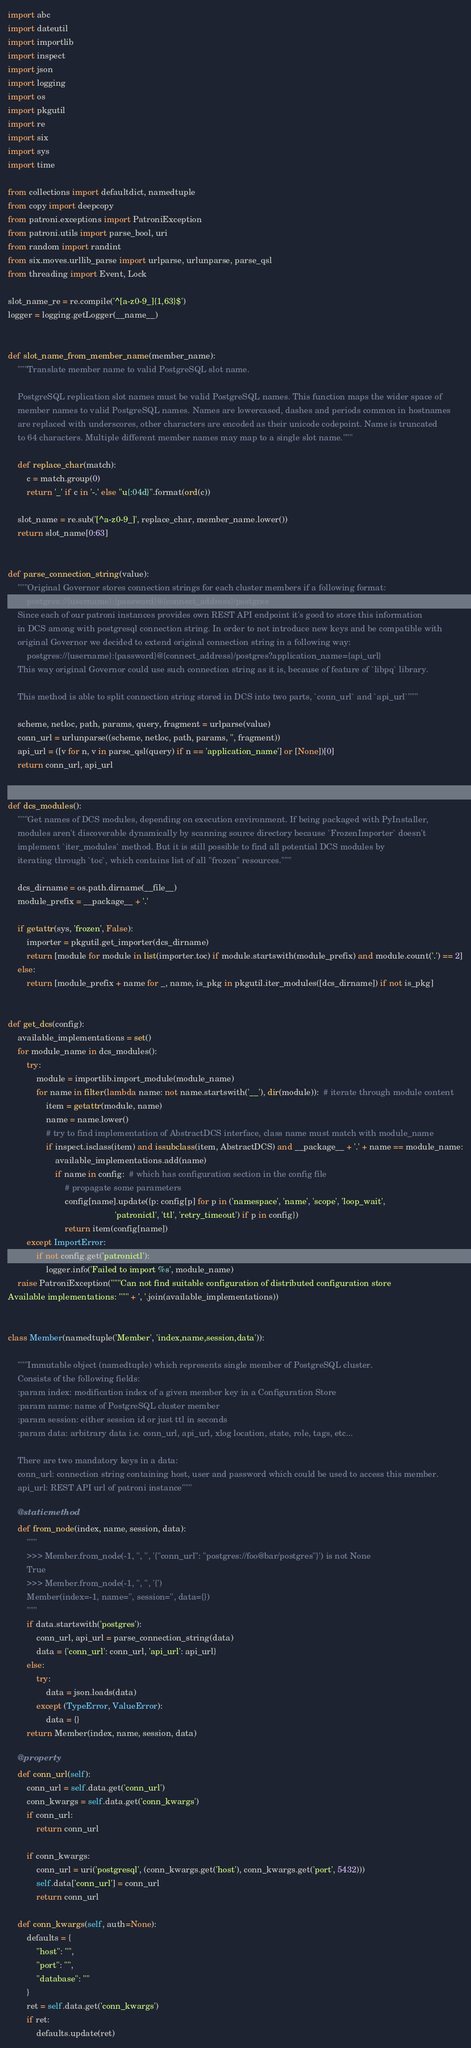<code> <loc_0><loc_0><loc_500><loc_500><_Python_>import abc
import dateutil
import importlib
import inspect
import json
import logging
import os
import pkgutil
import re
import six
import sys
import time

from collections import defaultdict, namedtuple
from copy import deepcopy
from patroni.exceptions import PatroniException
from patroni.utils import parse_bool, uri
from random import randint
from six.moves.urllib_parse import urlparse, urlunparse, parse_qsl
from threading import Event, Lock

slot_name_re = re.compile('^[a-z0-9_]{1,63}$')
logger = logging.getLogger(__name__)


def slot_name_from_member_name(member_name):
    """Translate member name to valid PostgreSQL slot name.

    PostgreSQL replication slot names must be valid PostgreSQL names. This function maps the wider space of
    member names to valid PostgreSQL names. Names are lowercased, dashes and periods common in hostnames
    are replaced with underscores, other characters are encoded as their unicode codepoint. Name is truncated
    to 64 characters. Multiple different member names may map to a single slot name."""

    def replace_char(match):
        c = match.group(0)
        return '_' if c in '-.' else "u{:04d}".format(ord(c))

    slot_name = re.sub('[^a-z0-9_]', replace_char, member_name.lower())
    return slot_name[0:63]


def parse_connection_string(value):
    """Original Governor stores connection strings for each cluster members if a following format:
        postgres://{username}:{password}@{connect_address}/postgres
    Since each of our patroni instances provides own REST API endpoint it's good to store this information
    in DCS among with postgresql connection string. In order to not introduce new keys and be compatible with
    original Governor we decided to extend original connection string in a following way:
        postgres://{username}:{password}@{connect_address}/postgres?application_name={api_url}
    This way original Governor could use such connection string as it is, because of feature of `libpq` library.

    This method is able to split connection string stored in DCS into two parts, `conn_url` and `api_url`"""

    scheme, netloc, path, params, query, fragment = urlparse(value)
    conn_url = urlunparse((scheme, netloc, path, params, '', fragment))
    api_url = ([v for n, v in parse_qsl(query) if n == 'application_name'] or [None])[0]
    return conn_url, api_url


def dcs_modules():
    """Get names of DCS modules, depending on execution environment. If being packaged with PyInstaller,
    modules aren't discoverable dynamically by scanning source directory because `FrozenImporter` doesn't
    implement `iter_modules` method. But it is still possible to find all potential DCS modules by
    iterating through `toc`, which contains list of all "frozen" resources."""

    dcs_dirname = os.path.dirname(__file__)
    module_prefix = __package__ + '.'

    if getattr(sys, 'frozen', False):
        importer = pkgutil.get_importer(dcs_dirname)
        return [module for module in list(importer.toc) if module.startswith(module_prefix) and module.count('.') == 2]
    else:
        return [module_prefix + name for _, name, is_pkg in pkgutil.iter_modules([dcs_dirname]) if not is_pkg]


def get_dcs(config):
    available_implementations = set()
    for module_name in dcs_modules():
        try:
            module = importlib.import_module(module_name)
            for name in filter(lambda name: not name.startswith('__'), dir(module)):  # iterate through module content
                item = getattr(module, name)
                name = name.lower()
                # try to find implementation of AbstractDCS interface, class name must match with module_name
                if inspect.isclass(item) and issubclass(item, AbstractDCS) and __package__ + '.' + name == module_name:
                    available_implementations.add(name)
                    if name in config:  # which has configuration section in the config file
                        # propagate some parameters
                        config[name].update({p: config[p] for p in ('namespace', 'name', 'scope', 'loop_wait',
                                             'patronictl', 'ttl', 'retry_timeout') if p in config})
                        return item(config[name])
        except ImportError:
            if not config.get('patronictl'):
                logger.info('Failed to import %s', module_name)
    raise PatroniException("""Can not find suitable configuration of distributed configuration store
Available implementations: """ + ', '.join(available_implementations))


class Member(namedtuple('Member', 'index,name,session,data')):

    """Immutable object (namedtuple) which represents single member of PostgreSQL cluster.
    Consists of the following fields:
    :param index: modification index of a given member key in a Configuration Store
    :param name: name of PostgreSQL cluster member
    :param session: either session id or just ttl in seconds
    :param data: arbitrary data i.e. conn_url, api_url, xlog location, state, role, tags, etc...

    There are two mandatory keys in a data:
    conn_url: connection string containing host, user and password which could be used to access this member.
    api_url: REST API url of patroni instance"""

    @staticmethod
    def from_node(index, name, session, data):
        """
        >>> Member.from_node(-1, '', '', '{"conn_url": "postgres://foo@bar/postgres"}') is not None
        True
        >>> Member.from_node(-1, '', '', '{')
        Member(index=-1, name='', session='', data={})
        """
        if data.startswith('postgres'):
            conn_url, api_url = parse_connection_string(data)
            data = {'conn_url': conn_url, 'api_url': api_url}
        else:
            try:
                data = json.loads(data)
            except (TypeError, ValueError):
                data = {}
        return Member(index, name, session, data)

    @property
    def conn_url(self):
        conn_url = self.data.get('conn_url')
        conn_kwargs = self.data.get('conn_kwargs')
        if conn_url:
            return conn_url

        if conn_kwargs:
            conn_url = uri('postgresql', (conn_kwargs.get('host'), conn_kwargs.get('port', 5432)))
            self.data['conn_url'] = conn_url
            return conn_url

    def conn_kwargs(self, auth=None):
        defaults = {
            "host": "",
            "port": "",
            "database": ""
        }
        ret = self.data.get('conn_kwargs')
        if ret:
            defaults.update(ret)</code> 